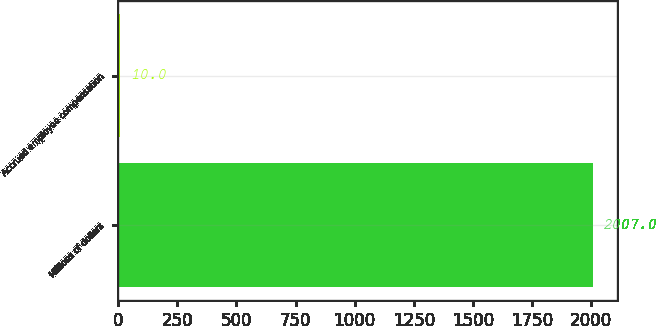Convert chart. <chart><loc_0><loc_0><loc_500><loc_500><bar_chart><fcel>Millions of dollars<fcel>Accrued employee compensation<nl><fcel>2007<fcel>10<nl></chart> 